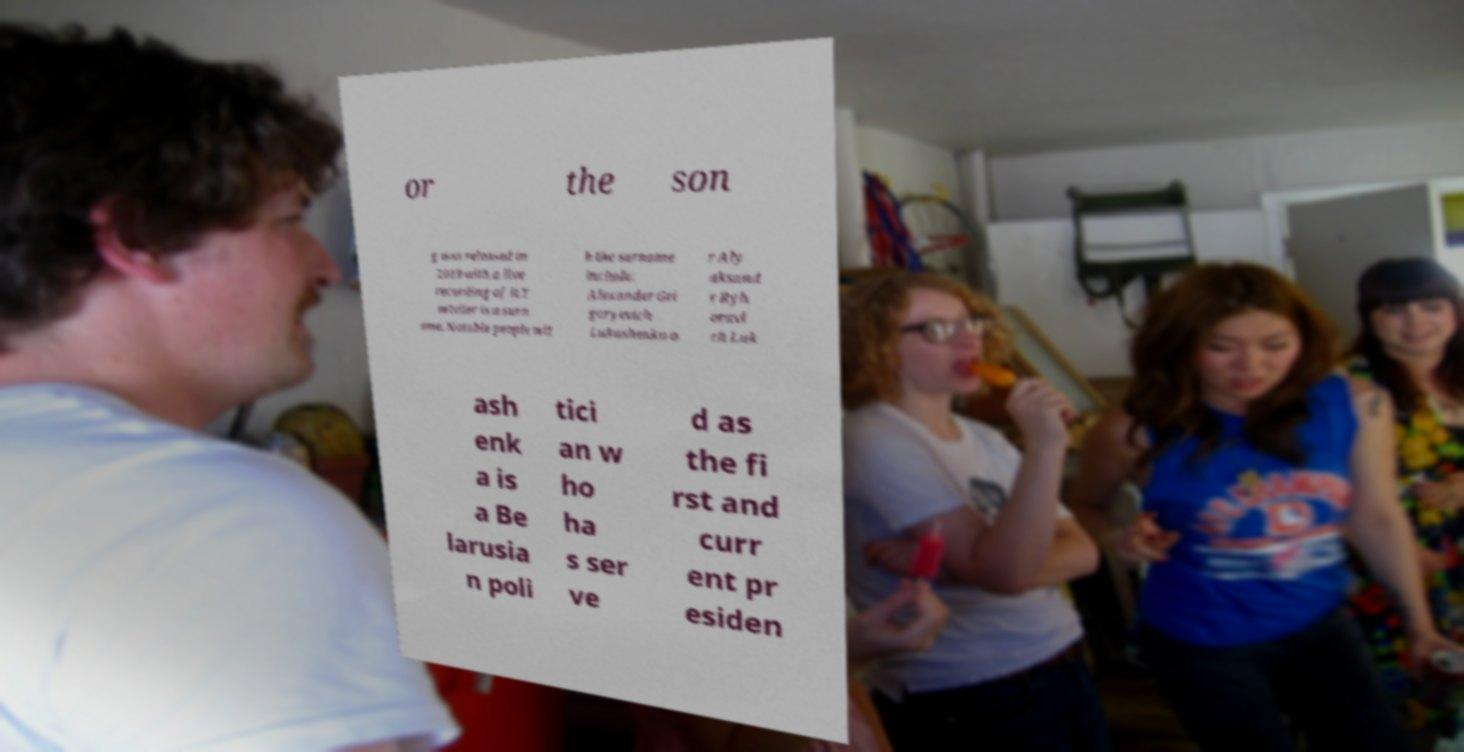For documentation purposes, I need the text within this image transcribed. Could you provide that? or the son g was released in 2019 with a live recording of it.T ortelier is a surn ame. Notable people wit h the surname include: Alexander Gri goryevich Lukashenko o r Aly aksand r Ryh oravi ch Luk ash enk a is a Be larusia n poli tici an w ho ha s ser ve d as the fi rst and curr ent pr esiden 